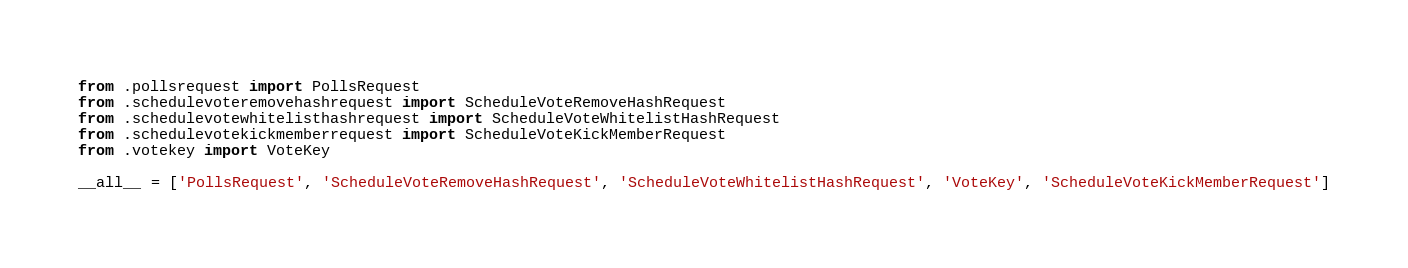Convert code to text. <code><loc_0><loc_0><loc_500><loc_500><_Python_>from .pollsrequest import PollsRequest
from .schedulevoteremovehashrequest import ScheduleVoteRemoveHashRequest
from .schedulevotewhitelisthashrequest import ScheduleVoteWhitelistHashRequest
from .schedulevotekickmemberrequest import ScheduleVoteKickMemberRequest
from .votekey import VoteKey

__all__ = ['PollsRequest', 'ScheduleVoteRemoveHashRequest', 'ScheduleVoteWhitelistHashRequest', 'VoteKey', 'ScheduleVoteKickMemberRequest']
</code> 